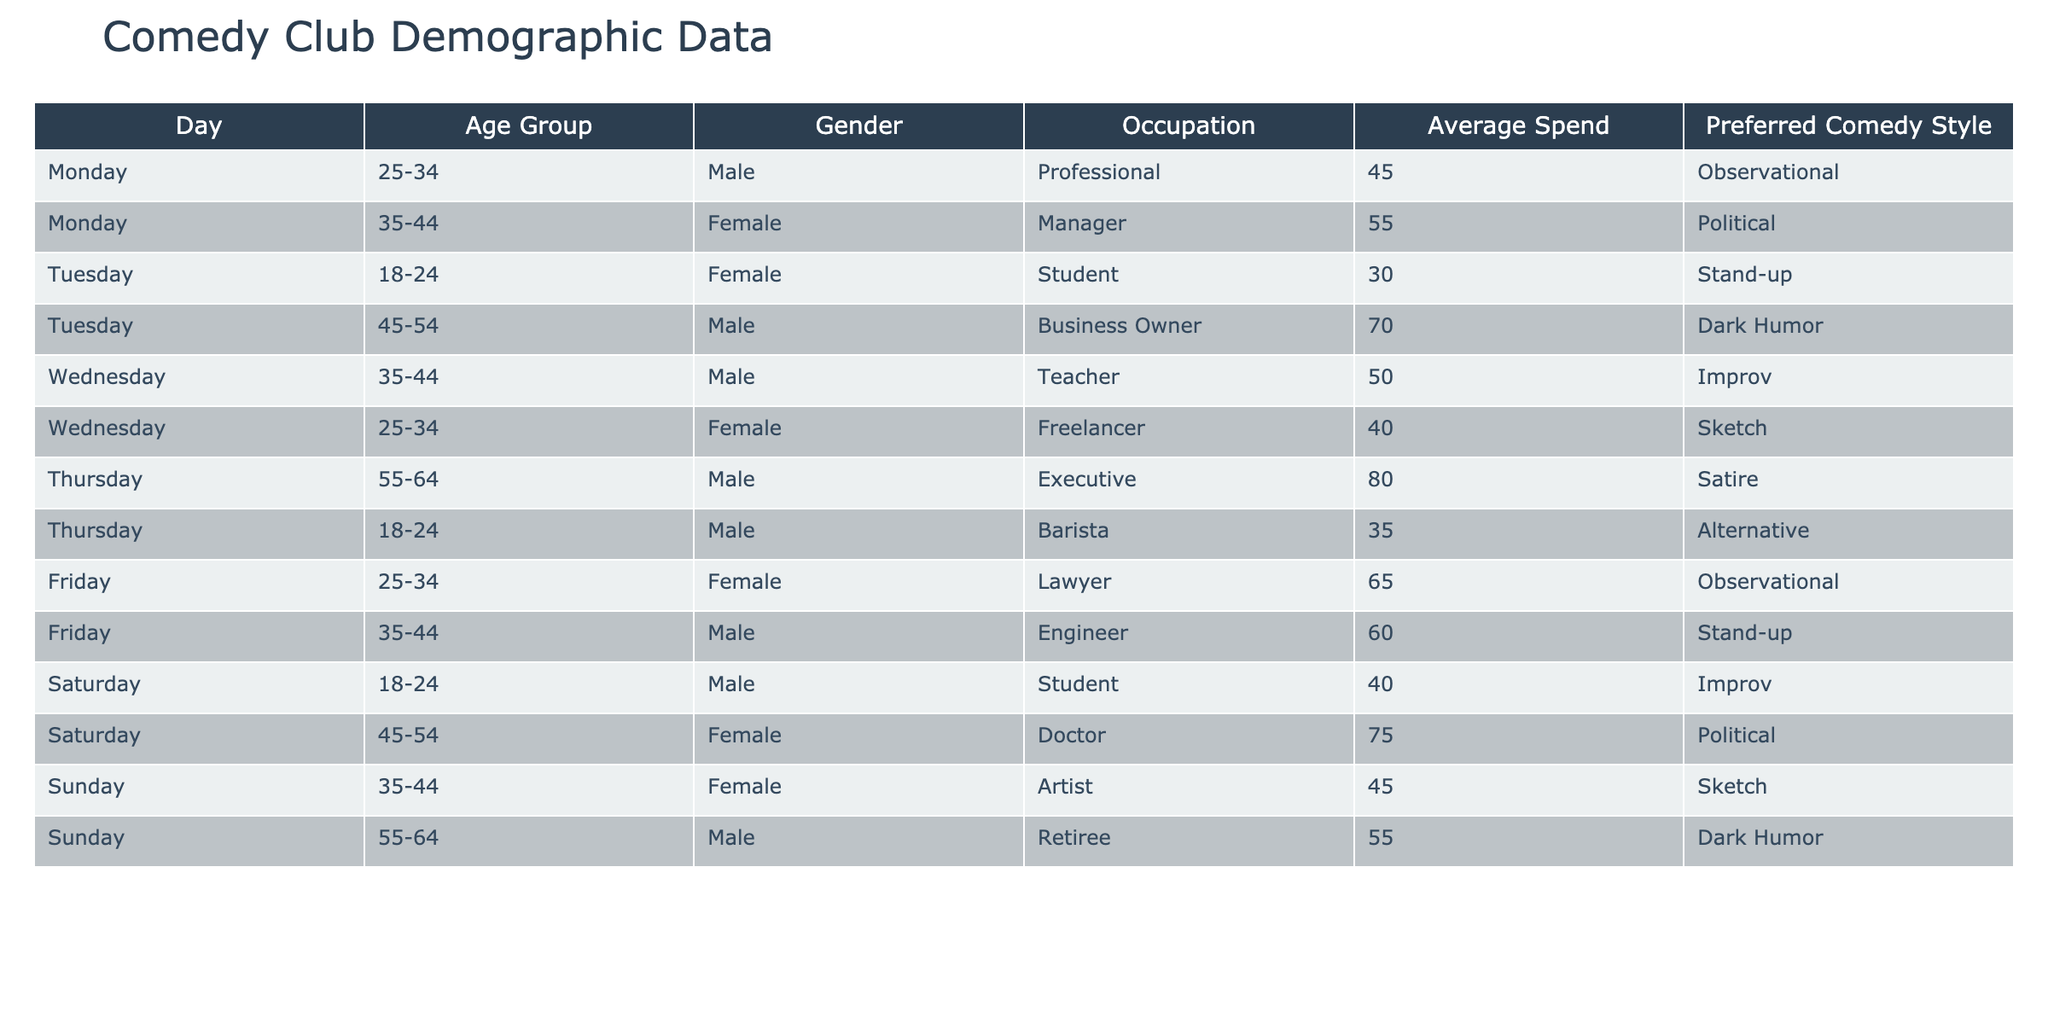What is the average spend of attendees on Friday? There are two data points for Friday: a Female at 65 and a Male at 60. Therefore, the average is (65 + 60) / 2 = 62.5.
Answer: 62.5 Which age group is most represented among attendees on Sunday? There are two entries for Sunday: 35-44 and 55-64. The most frequent age group, 35-44, has one Female and one Male.
Answer: 35-44 How many female attendees prefer Political comedy on Tuesday and Saturday combined? On Tuesday, there is one Female attendee who prefers Political comedy, and on Saturday, there is no Female attendee with that preference. So, the total is 1 + 0 = 1.
Answer: 1 Is there any male attendee in the age group 55-64 on Thursday? Yes, there is one Male attendee in the 55-64 age group on Thursday. This attendee is an Executive.
Answer: Yes What is the total average spend of all attendees across all days? The average spend for all attendees is calculated by summing all the average spends: 45 + 55 + 30 + 70 + 50 + 40 + 80 + 35 + 65 + 60 + 40 + 75 + 45 + 55 = 675. There are 14 attendees, so the total average spend is 675 / 14 ≈ 48.21.
Answer: 48.21 Which comedy style is preferred by the oldest age group attending on Thursday? The oldest attendees on Thursday are in the 55-64 age group, and the preferred comedy style for the Male Executive is Satire.
Answer: Satire What is the gender distribution for attendees on Wednesday? On Wednesday, there are two attendees: one Male (35-44) and one Female (25-34). Thus, it is 1 Male and 1 Female.
Answer: 1 Male, 1 Female How does the average spend of attendees on Monday compare to Tuesday? The average spend on Monday is (45 + 55) / 2 = 50, and on Tuesday it is (30 + 70) / 2 = 50. They are equal.
Answer: Equal Which comedy style is preferred by attendees in the 45-54 age group attending on weekends? The 45-54 age group on Saturday shows a Male Student who prefers Improv, and on Sunday a Female Doctor prefers Political. So, both Improv and Political are preferred styles.
Answer: Improv and Political What is the combined spend of all Male attendees on Friday and Saturday? On Friday, the Male spend is 60, and on Saturday, the Male spend is 40. Thus combined, their spend is 60 + 40 = 100.
Answer: 100 